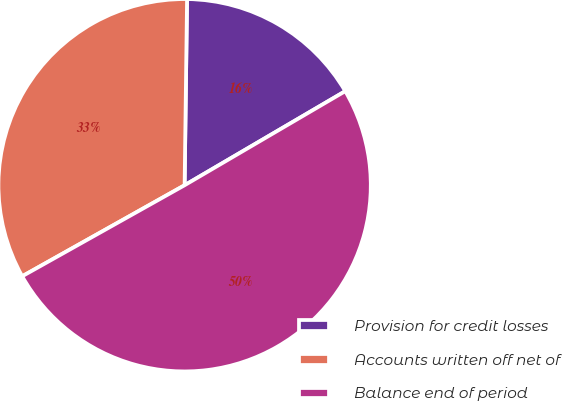Convert chart. <chart><loc_0><loc_0><loc_500><loc_500><pie_chart><fcel>Provision for credit losses<fcel>Accounts written off net of<fcel>Balance end of period<nl><fcel>16.36%<fcel>33.34%<fcel>50.3%<nl></chart> 